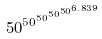<formula> <loc_0><loc_0><loc_500><loc_500>5 0 ^ { 5 0 ^ { 5 0 ^ { 5 0 ^ { 5 0 ^ { 6 . 8 3 9 } } } } }</formula> 